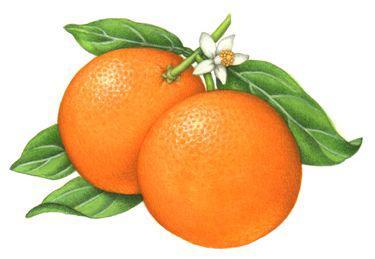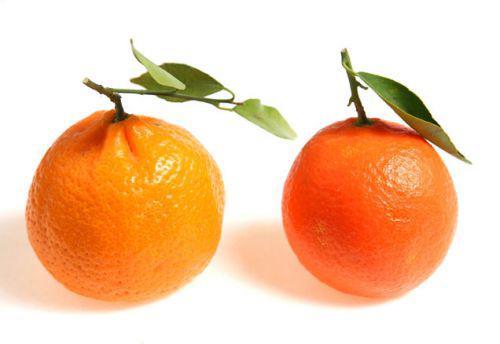The first image is the image on the left, the second image is the image on the right. Evaluate the accuracy of this statement regarding the images: "The right image contains at least one orange that is sliced in half.". Is it true? Answer yes or no. No. The first image is the image on the left, the second image is the image on the right. Evaluate the accuracy of this statement regarding the images: "There are three whole oranges and a half an orange in the image pair.". Is it true? Answer yes or no. No. 